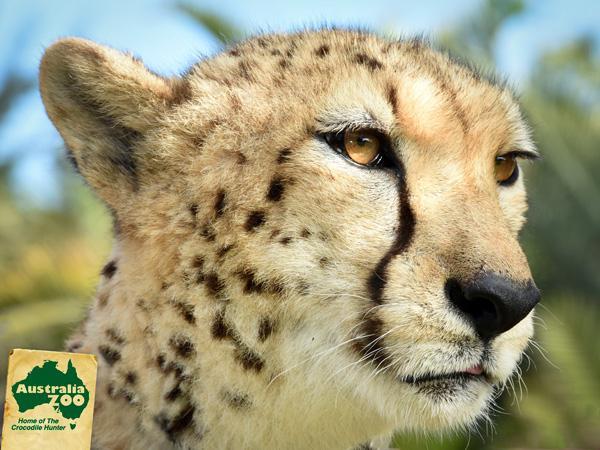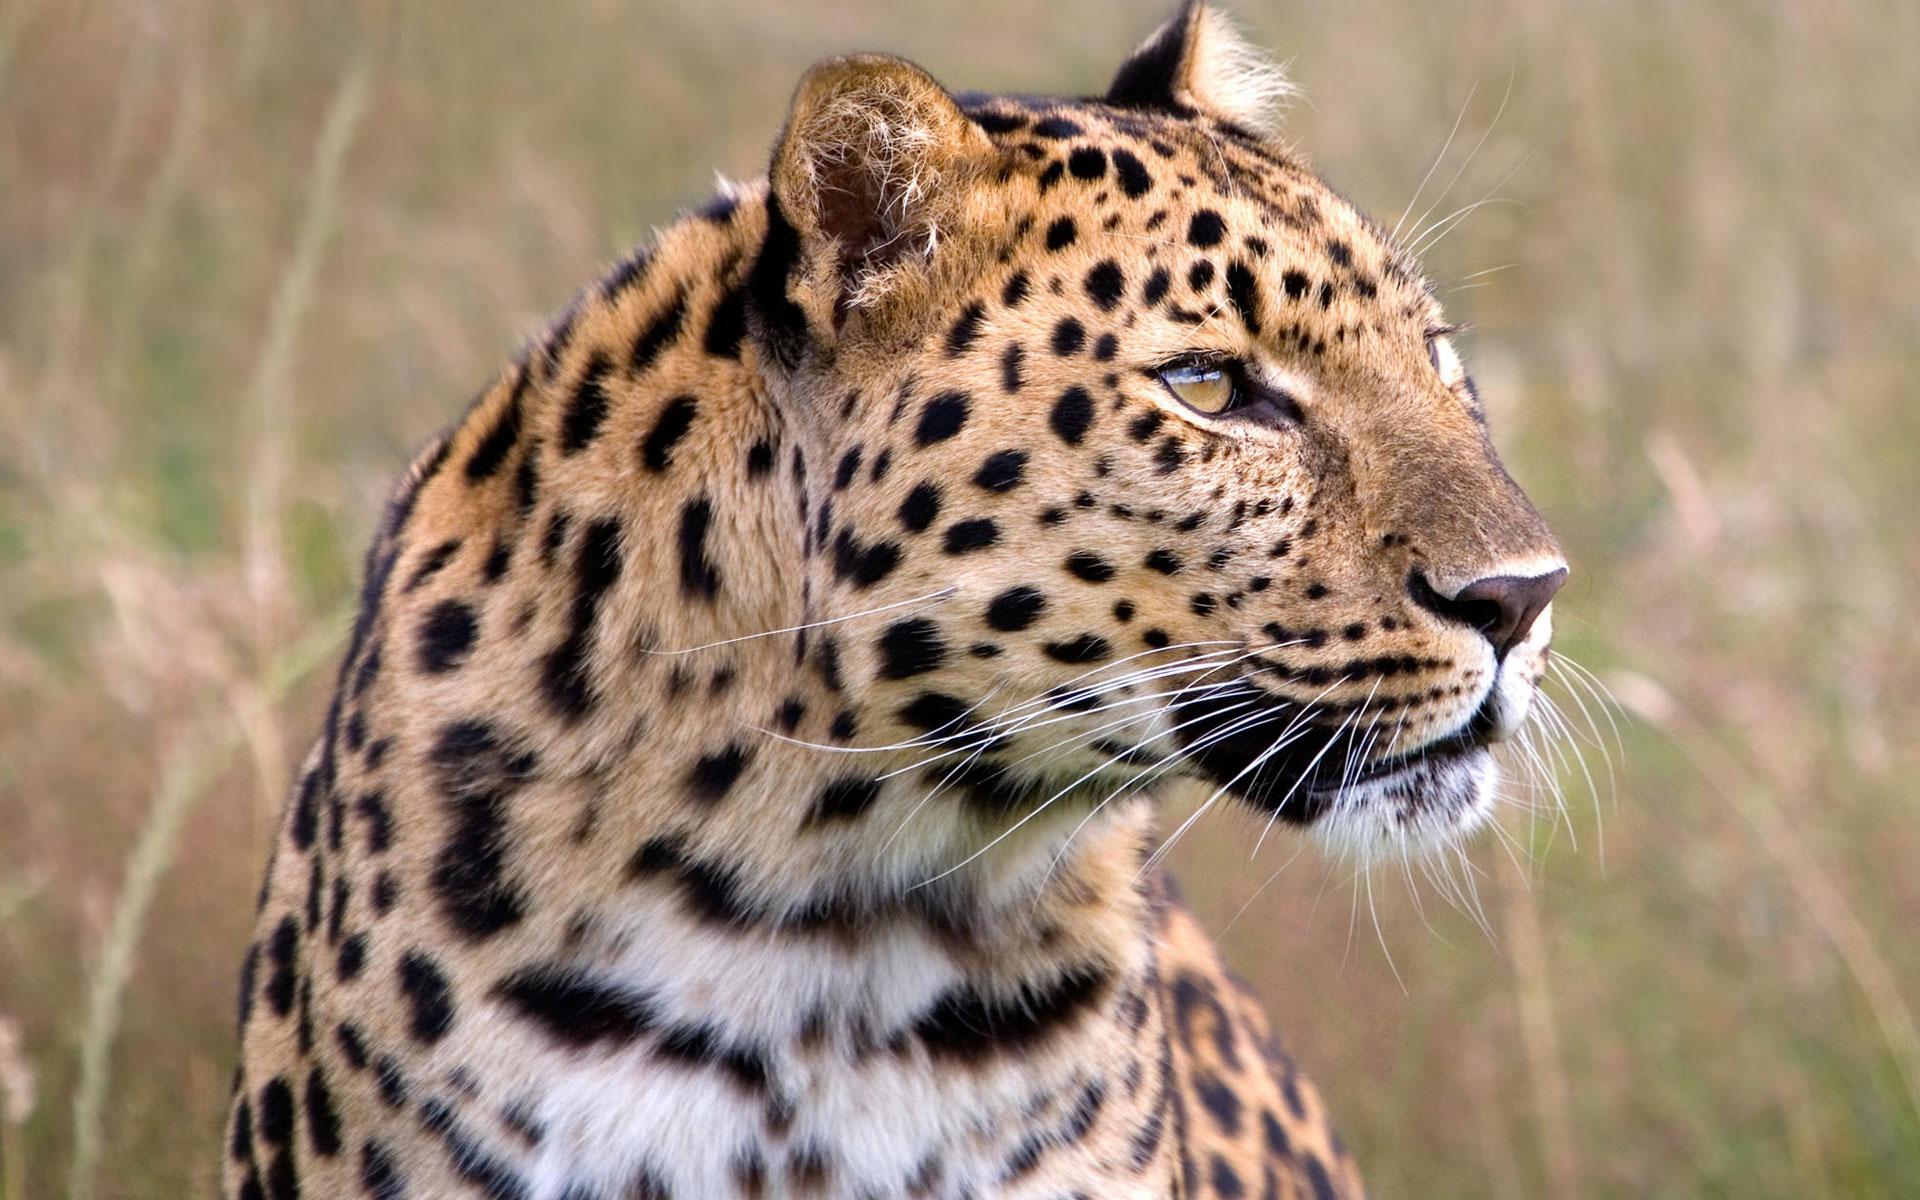The first image is the image on the left, the second image is the image on the right. Given the left and right images, does the statement "Each image shows a single spotted wild cat, and each cat is in a similar type of pose." hold true? Answer yes or no. Yes. 